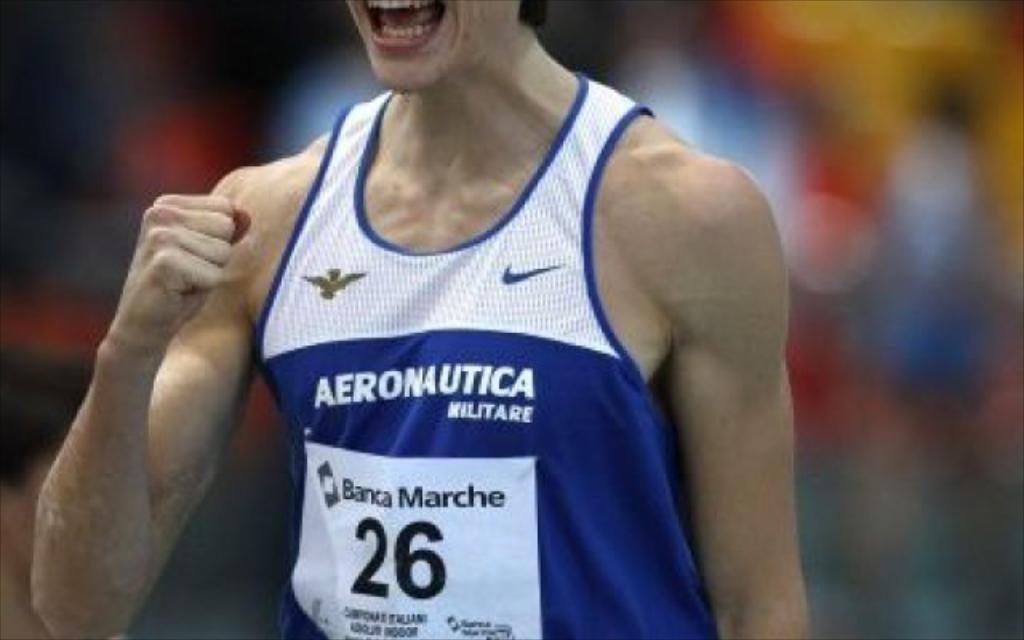<image>
Create a compact narrative representing the image presented. An athelete numbered 26 wears a white and blue vest with Aeronautica Miltare and Banac Marche on it. 